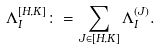Convert formula to latex. <formula><loc_0><loc_0><loc_500><loc_500>\Lambda _ { I } ^ { [ H , K ] } \colon = \sum _ { J \in [ H , K ] } \Lambda _ { I } ^ { ( J ) } .</formula> 